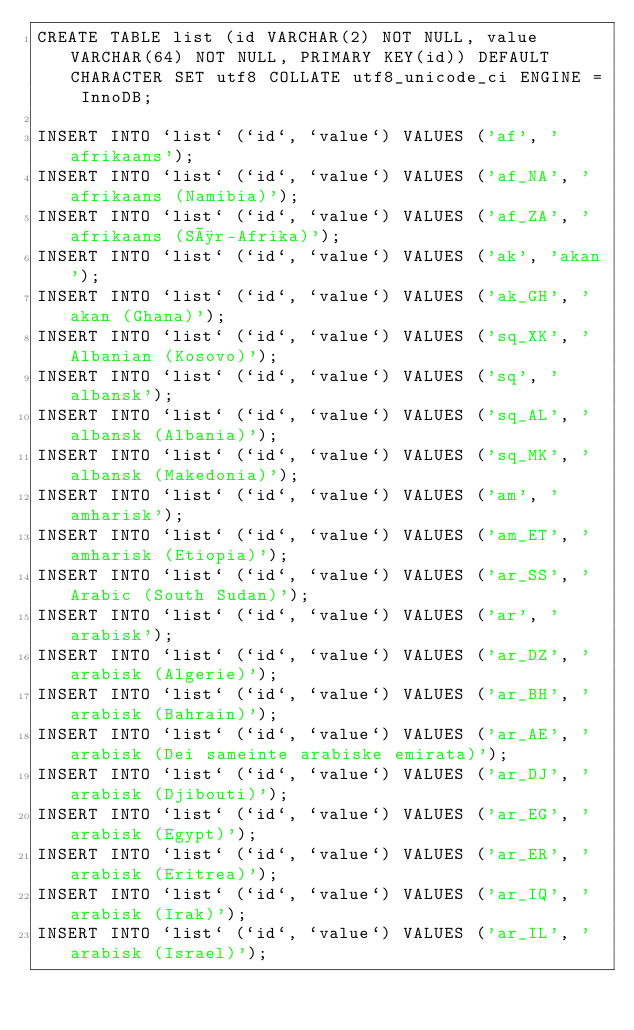<code> <loc_0><loc_0><loc_500><loc_500><_SQL_>CREATE TABLE list (id VARCHAR(2) NOT NULL, value VARCHAR(64) NOT NULL, PRIMARY KEY(id)) DEFAULT CHARACTER SET utf8 COLLATE utf8_unicode_ci ENGINE = InnoDB;

INSERT INTO `list` (`id`, `value`) VALUES ('af', 'afrikaans');
INSERT INTO `list` (`id`, `value`) VALUES ('af_NA', 'afrikaans (Namibia)');
INSERT INTO `list` (`id`, `value`) VALUES ('af_ZA', 'afrikaans (Sør-Afrika)');
INSERT INTO `list` (`id`, `value`) VALUES ('ak', 'akan');
INSERT INTO `list` (`id`, `value`) VALUES ('ak_GH', 'akan (Ghana)');
INSERT INTO `list` (`id`, `value`) VALUES ('sq_XK', 'Albanian (Kosovo)');
INSERT INTO `list` (`id`, `value`) VALUES ('sq', 'albansk');
INSERT INTO `list` (`id`, `value`) VALUES ('sq_AL', 'albansk (Albania)');
INSERT INTO `list` (`id`, `value`) VALUES ('sq_MK', 'albansk (Makedonia)');
INSERT INTO `list` (`id`, `value`) VALUES ('am', 'amharisk');
INSERT INTO `list` (`id`, `value`) VALUES ('am_ET', 'amharisk (Etiopia)');
INSERT INTO `list` (`id`, `value`) VALUES ('ar_SS', 'Arabic (South Sudan)');
INSERT INTO `list` (`id`, `value`) VALUES ('ar', 'arabisk');
INSERT INTO `list` (`id`, `value`) VALUES ('ar_DZ', 'arabisk (Algerie)');
INSERT INTO `list` (`id`, `value`) VALUES ('ar_BH', 'arabisk (Bahrain)');
INSERT INTO `list` (`id`, `value`) VALUES ('ar_AE', 'arabisk (Dei sameinte arabiske emirata)');
INSERT INTO `list` (`id`, `value`) VALUES ('ar_DJ', 'arabisk (Djibouti)');
INSERT INTO `list` (`id`, `value`) VALUES ('ar_EG', 'arabisk (Egypt)');
INSERT INTO `list` (`id`, `value`) VALUES ('ar_ER', 'arabisk (Eritrea)');
INSERT INTO `list` (`id`, `value`) VALUES ('ar_IQ', 'arabisk (Irak)');
INSERT INTO `list` (`id`, `value`) VALUES ('ar_IL', 'arabisk (Israel)');</code> 